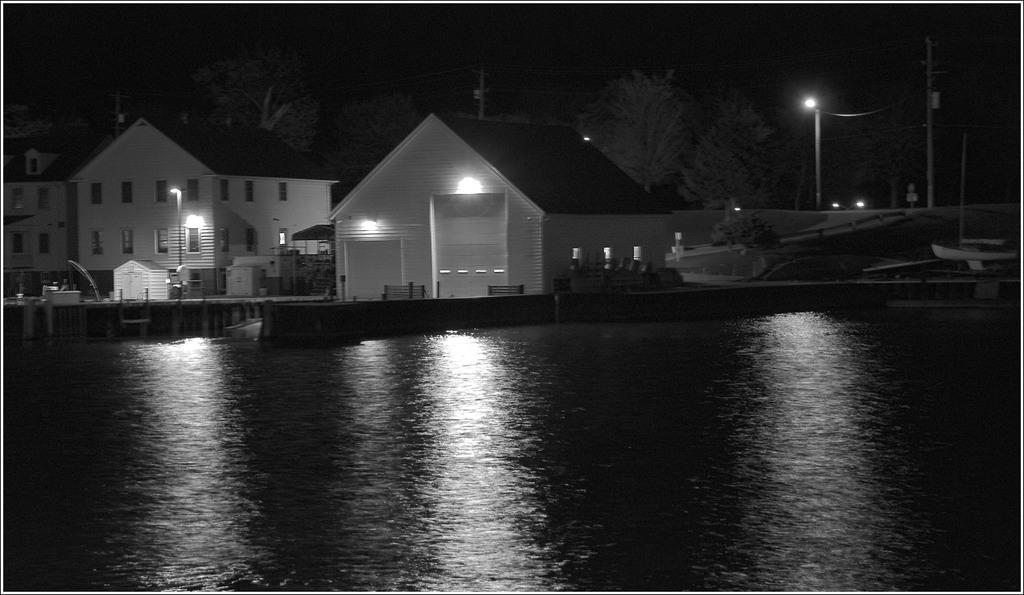Can you describe this image briefly? There is water surface in the foreground area of the image, there are houses, lamp poles and trees in the background. 